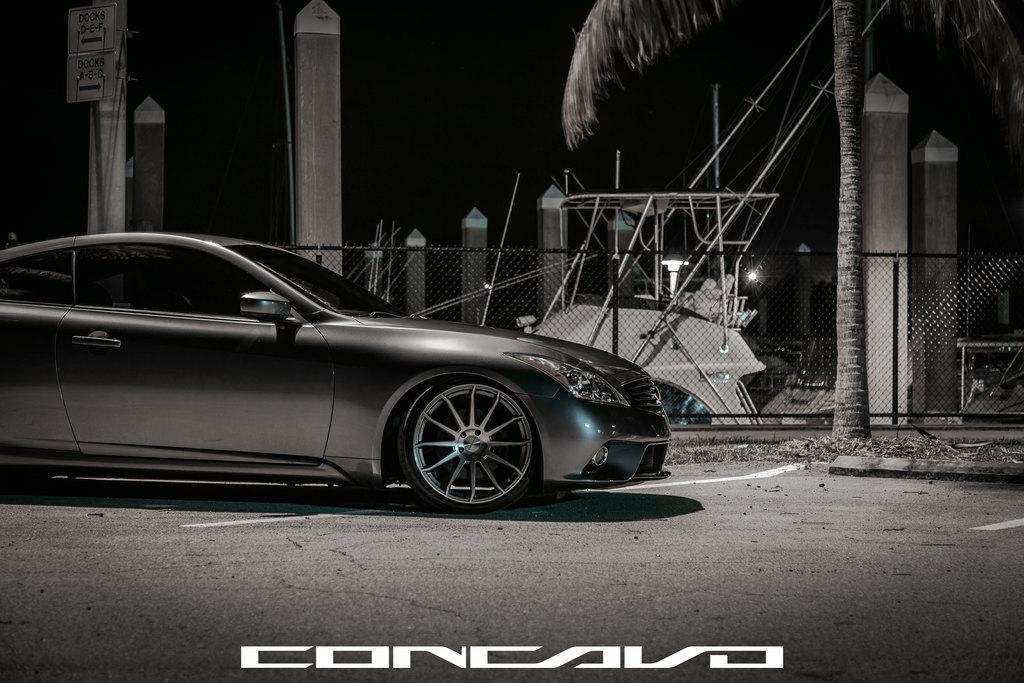What is the main subject of the image? There is a car on the road in the image. What can be seen in the background of the image? The sky is visible in the background of the image. What type of natural element is present in the image? There is a tree in the image. What architectural feature can be seen in the image? There is a fence in the image. What living creatures are present in the image? There are birds in the image. Can you describe the object in the image? There is an object in the image, but its specific details are not mentioned in the facts. What is the board to a pillar in the image used for? The purpose of the board to a pillar in the image is not mentioned in the facts. What type of religious feast is being celebrated in the image? There is no indication of a religious feast or any religious elements in the image. What type of stitch is being used to sew the birds together in the image? There are no birds being sewn together in the image; they are living creatures. 